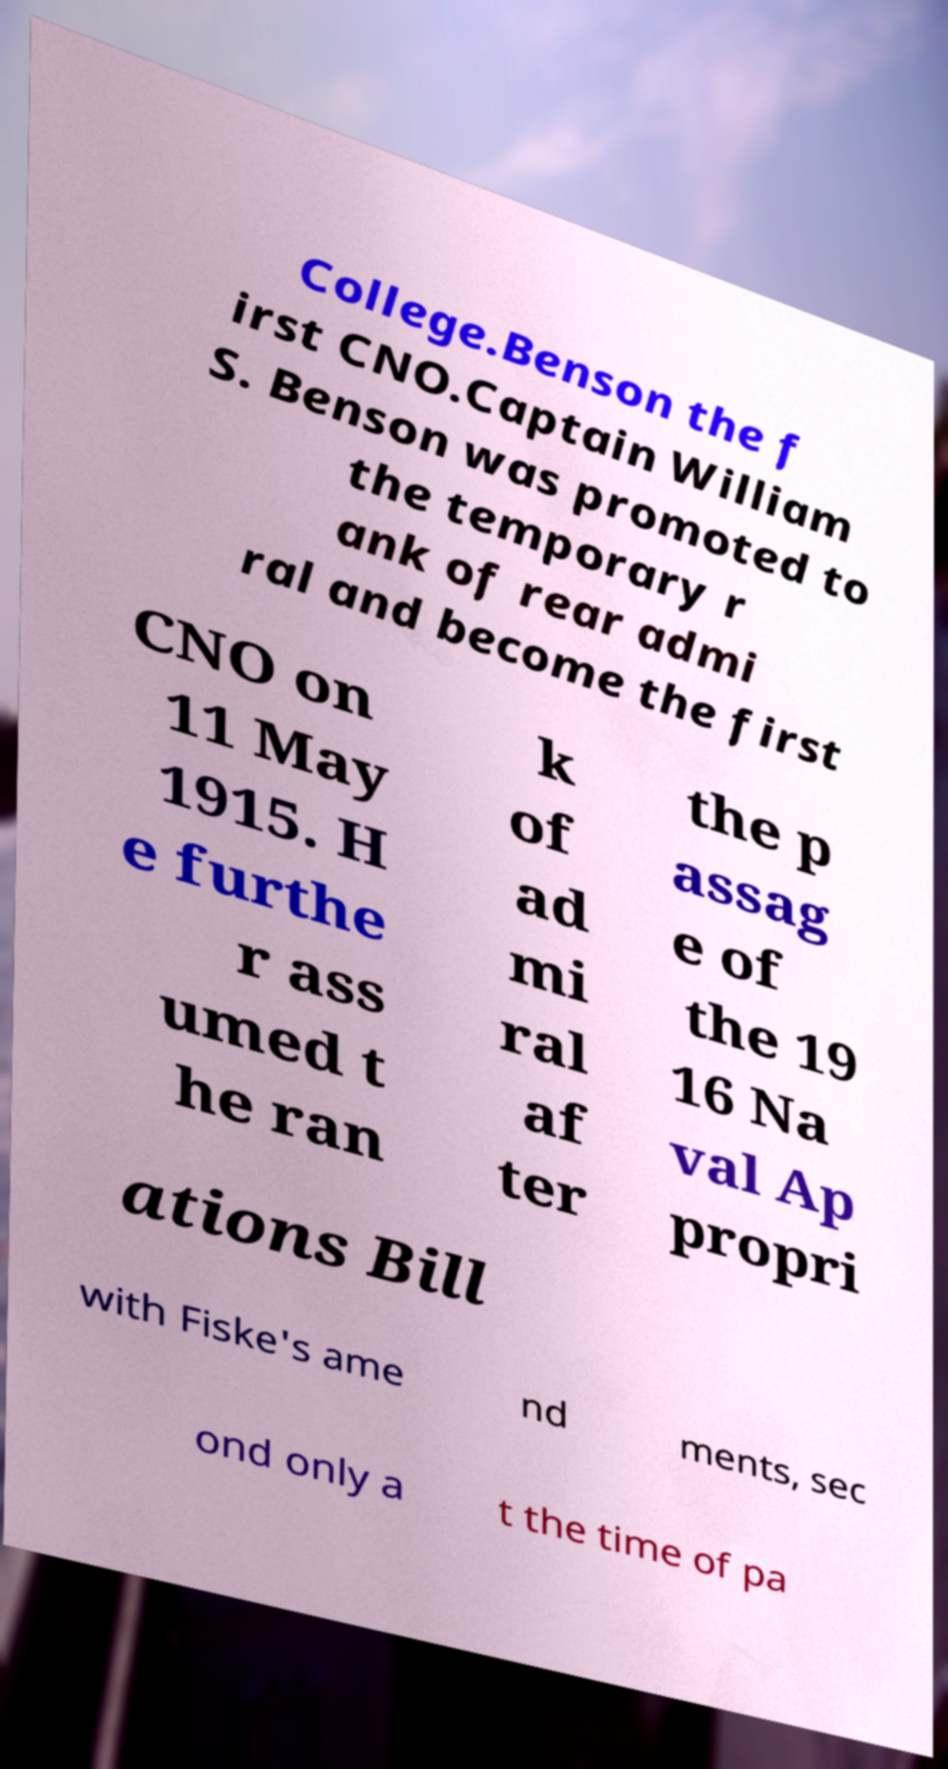Please identify and transcribe the text found in this image. College.Benson the f irst CNO.Captain William S. Benson was promoted to the temporary r ank of rear admi ral and become the first CNO on 11 May 1915. H e furthe r ass umed t he ran k of ad mi ral af ter the p assag e of the 19 16 Na val Ap propri ations Bill with Fiske's ame nd ments, sec ond only a t the time of pa 